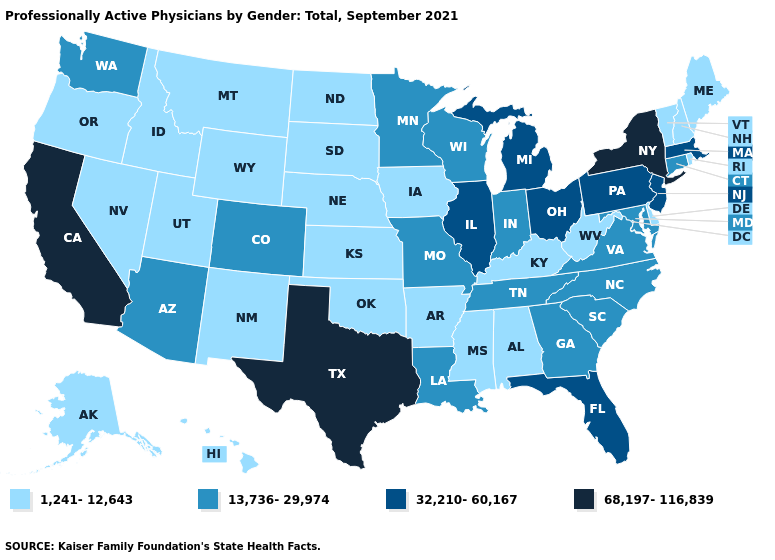Name the states that have a value in the range 32,210-60,167?
Write a very short answer. Florida, Illinois, Massachusetts, Michigan, New Jersey, Ohio, Pennsylvania. Does Alaska have the same value as Texas?
Keep it brief. No. Does Vermont have a lower value than Tennessee?
Keep it brief. Yes. Among the states that border Minnesota , does Wisconsin have the lowest value?
Write a very short answer. No. Does Florida have the lowest value in the South?
Quick response, please. No. Does the map have missing data?
Concise answer only. No. Is the legend a continuous bar?
Give a very brief answer. No. Does the map have missing data?
Answer briefly. No. Name the states that have a value in the range 68,197-116,839?
Answer briefly. California, New York, Texas. What is the value of Indiana?
Concise answer only. 13,736-29,974. Name the states that have a value in the range 1,241-12,643?
Give a very brief answer. Alabama, Alaska, Arkansas, Delaware, Hawaii, Idaho, Iowa, Kansas, Kentucky, Maine, Mississippi, Montana, Nebraska, Nevada, New Hampshire, New Mexico, North Dakota, Oklahoma, Oregon, Rhode Island, South Dakota, Utah, Vermont, West Virginia, Wyoming. Does Connecticut have the same value as Ohio?
Concise answer only. No. Does the map have missing data?
Write a very short answer. No. Among the states that border Connecticut , does Massachusetts have the highest value?
Answer briefly. No. What is the lowest value in the USA?
Be succinct. 1,241-12,643. 